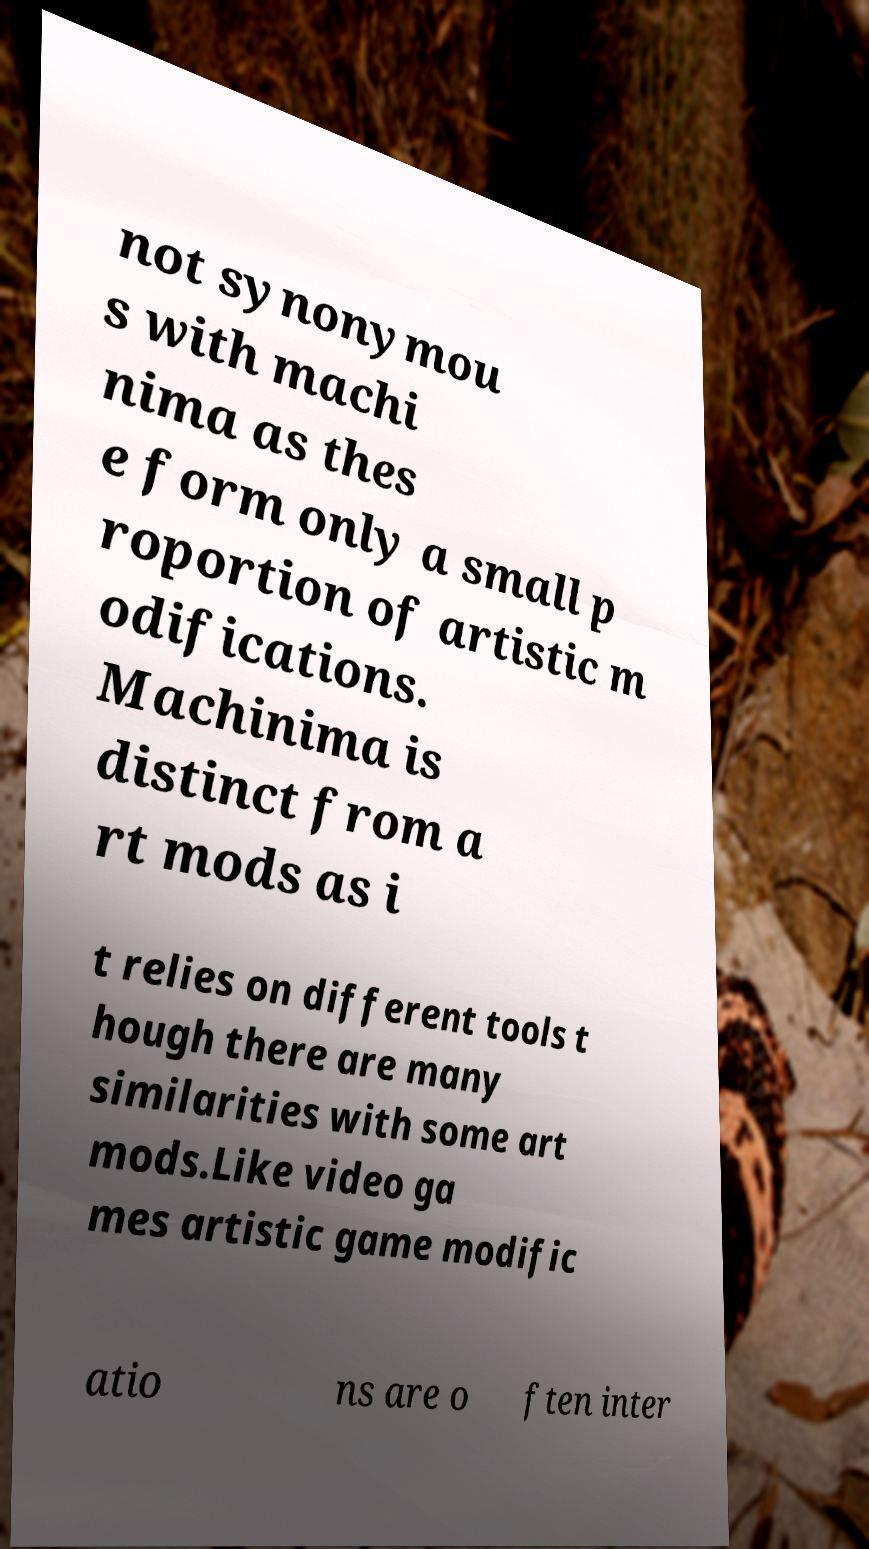Can you read and provide the text displayed in the image?This photo seems to have some interesting text. Can you extract and type it out for me? not synonymou s with machi nima as thes e form only a small p roportion of artistic m odifications. Machinima is distinct from a rt mods as i t relies on different tools t hough there are many similarities with some art mods.Like video ga mes artistic game modific atio ns are o ften inter 